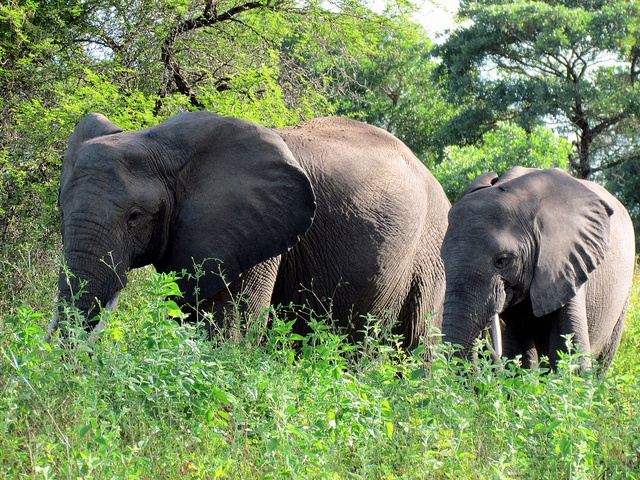Describe the objects in this image and their specific colors. I can see elephant in black, gray, darkgray, and tan tones and elephant in black, gray, darkgray, and lightgray tones in this image. 